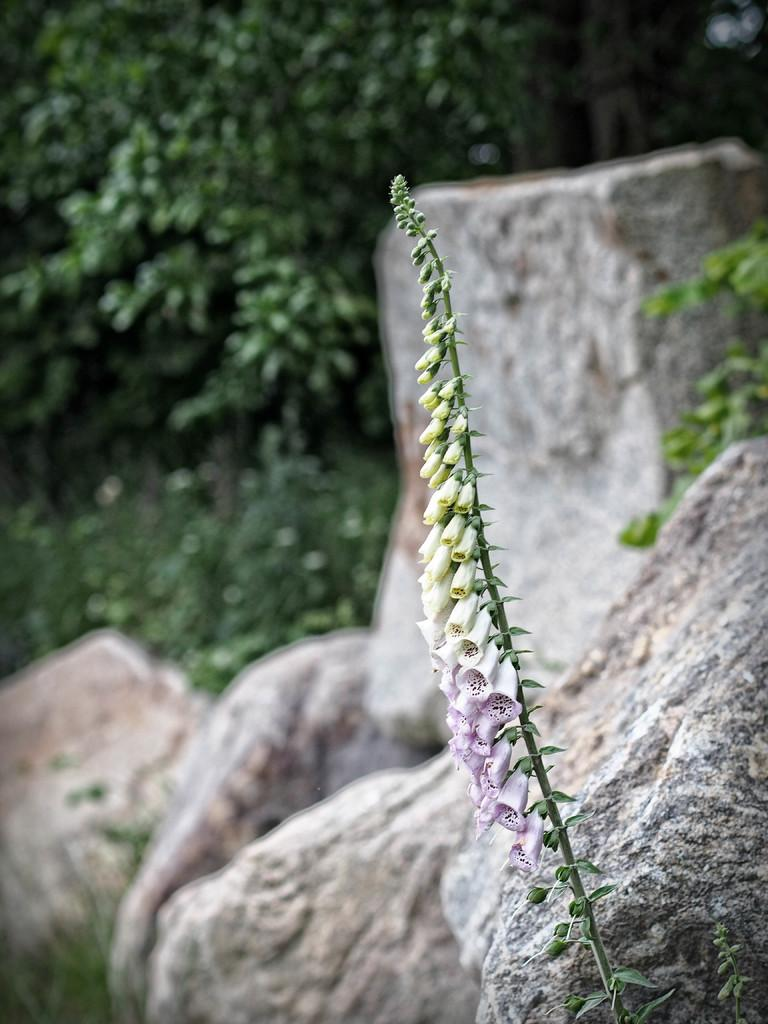What type of plant is in the picture? The plant in the picture has white flowers and yellow flowers. What other features can be seen on the plant? The plant has leaves. What is visible in the backdrop of the picture? There are rocks and plants in the backdrop of the picture. How is the backdrop of the picture depicted? The backdrop is blurred. How many kittens are participating in the event depicted in the image? There is no event or kittens present in the image; it features a plant with flowers and leaves. What type of division is shown in the image? There is no division or separation depicted in the image; it focuses on a plant and its surroundings. 